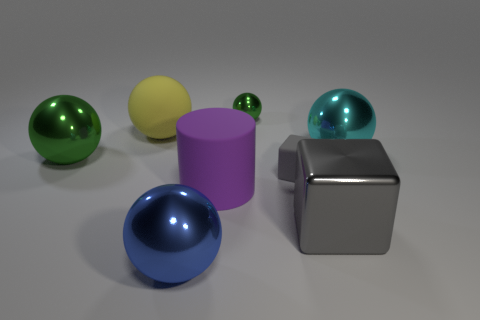Add 2 purple matte cylinders. How many objects exist? 10 Subtract all big spheres. How many spheres are left? 1 Subtract all cylinders. How many objects are left? 7 Subtract 3 spheres. How many spheres are left? 2 Subtract all yellow shiny cylinders. Subtract all spheres. How many objects are left? 3 Add 7 large cyan spheres. How many large cyan spheres are left? 8 Add 8 green shiny spheres. How many green shiny spheres exist? 10 Subtract all yellow spheres. How many spheres are left? 4 Subtract 0 cyan cubes. How many objects are left? 8 Subtract all green cylinders. Subtract all cyan blocks. How many cylinders are left? 1 